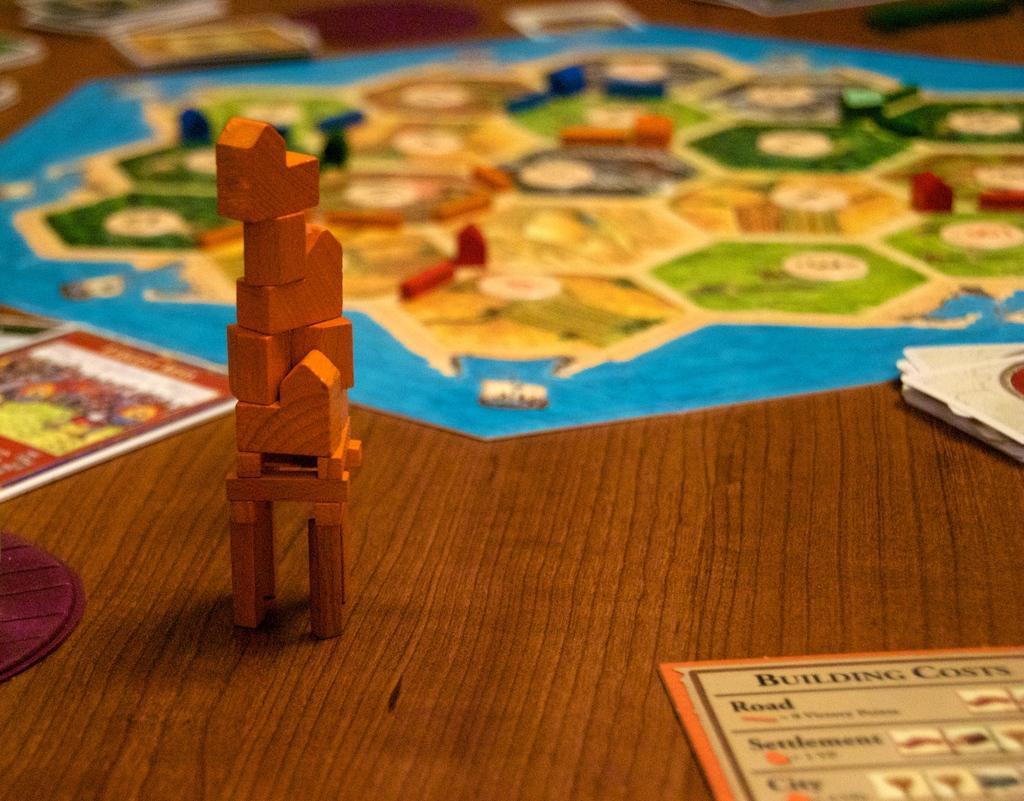How would you summarize this image in a sentence or two? In the image we can see wooden building blocks on the right side of the image. Here we can see the papers, wooden surface, paper game play and the background is blurred. 